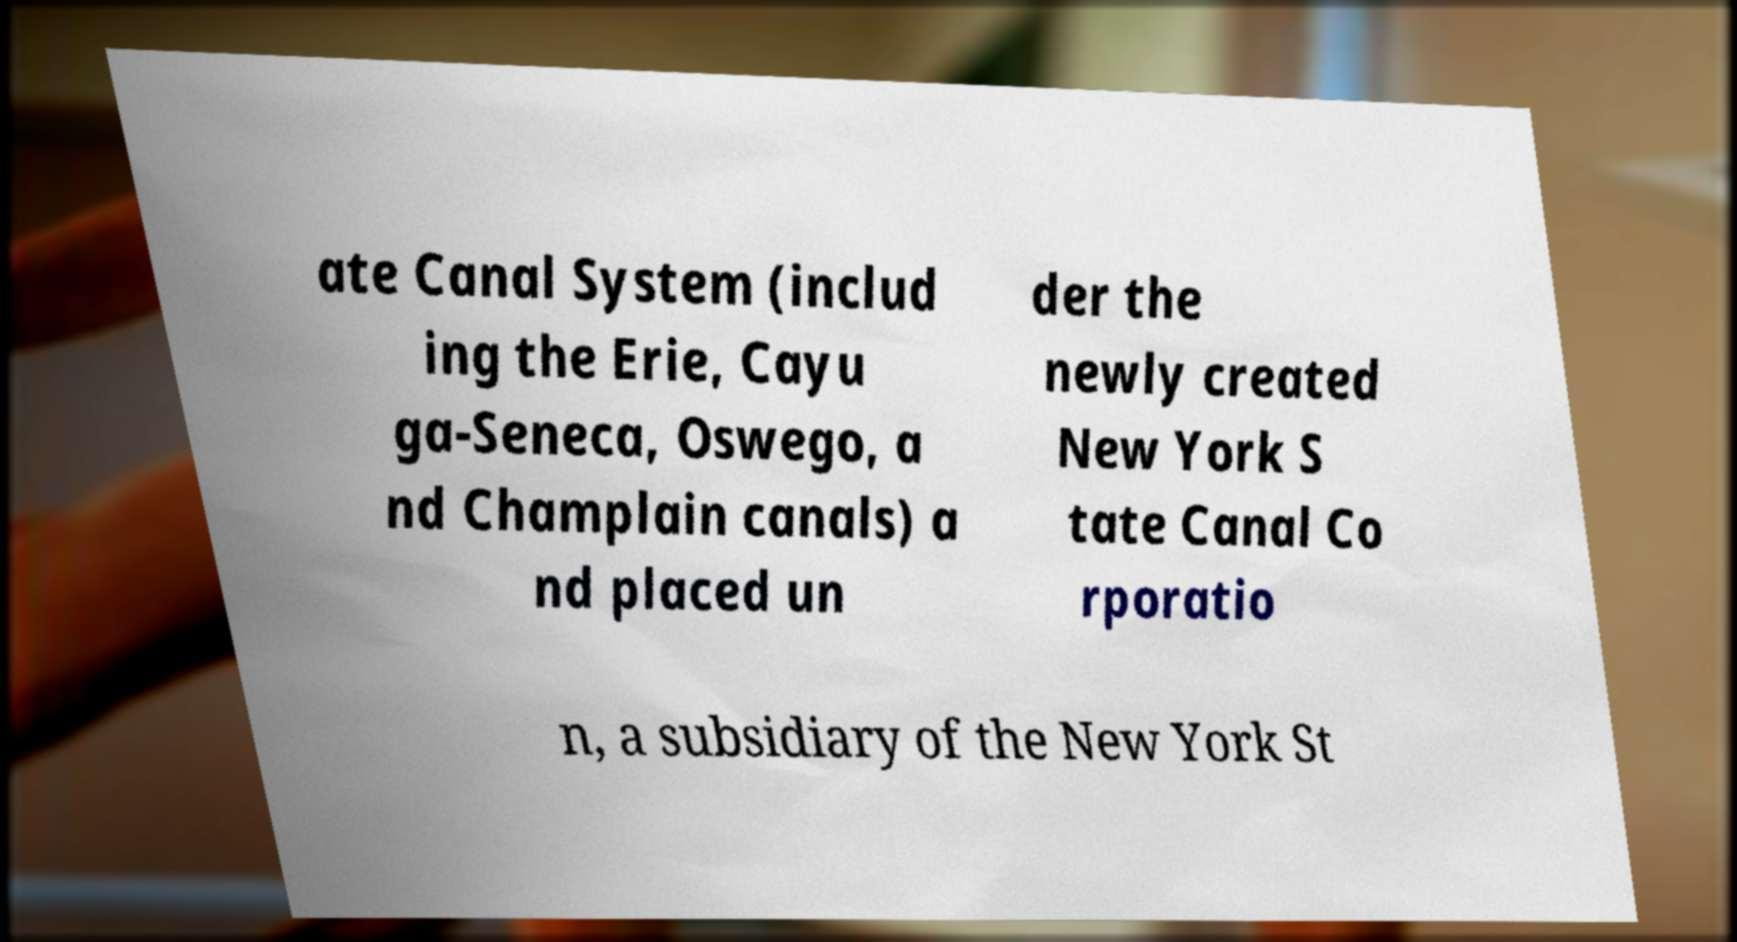Could you extract and type out the text from this image? ate Canal System (includ ing the Erie, Cayu ga-Seneca, Oswego, a nd Champlain canals) a nd placed un der the newly created New York S tate Canal Co rporatio n, a subsidiary of the New York St 